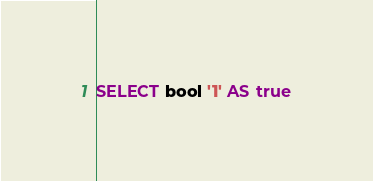<code> <loc_0><loc_0><loc_500><loc_500><_SQL_>SELECT bool '1' AS true
</code> 